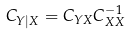<formula> <loc_0><loc_0><loc_500><loc_500>C _ { Y | X } = C _ { Y X } C _ { X X } ^ { - 1 }</formula> 